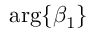<formula> <loc_0><loc_0><loc_500><loc_500>\arg \{ \beta _ { 1 } \}</formula> 